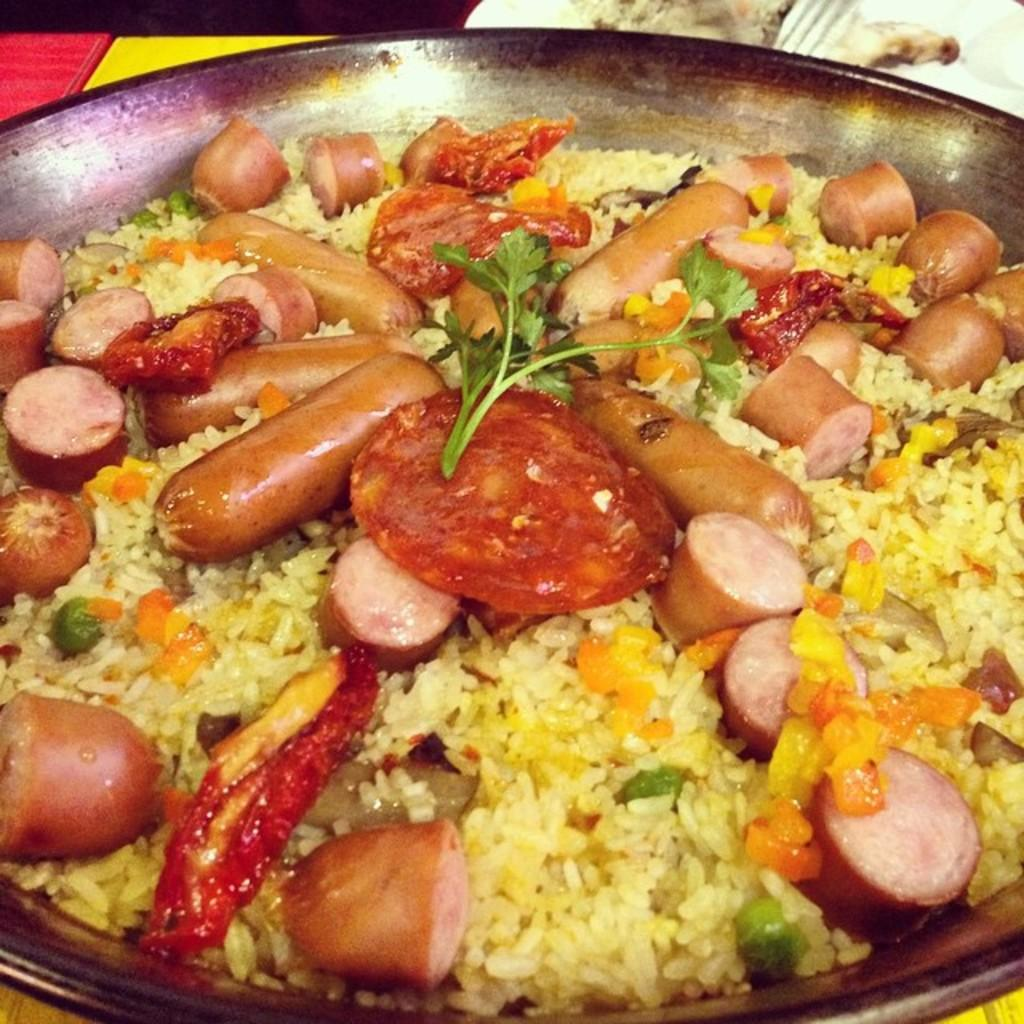What type of food is visible in the image? There is rice in the image. What else is present in the image besides rice? There are vegetables in the image. How are the rice and vegetables arranged in the image? The rice and vegetables are in a pan. What type of scissors can be seen cutting the vegetables in the image? There are no scissors present in the image, and the vegetables are not being cut. 